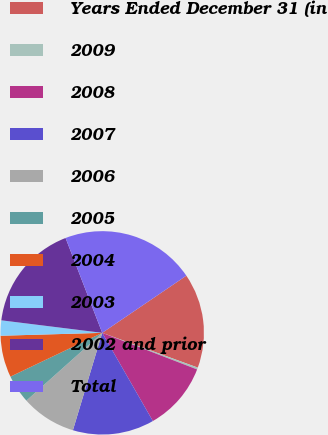Convert chart to OTSL. <chart><loc_0><loc_0><loc_500><loc_500><pie_chart><fcel>Years Ended December 31 (in<fcel>2009<fcel>2008<fcel>2007<fcel>2006<fcel>2005<fcel>2004<fcel>2003<fcel>2002 and prior<fcel>Total<nl><fcel>15.05%<fcel>0.31%<fcel>10.84%<fcel>12.95%<fcel>8.74%<fcel>4.52%<fcel>6.63%<fcel>2.42%<fcel>17.16%<fcel>21.37%<nl></chart> 